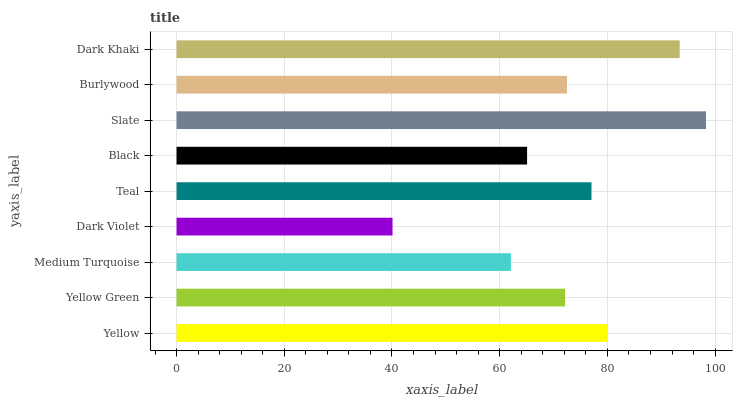Is Dark Violet the minimum?
Answer yes or no. Yes. Is Slate the maximum?
Answer yes or no. Yes. Is Yellow Green the minimum?
Answer yes or no. No. Is Yellow Green the maximum?
Answer yes or no. No. Is Yellow greater than Yellow Green?
Answer yes or no. Yes. Is Yellow Green less than Yellow?
Answer yes or no. Yes. Is Yellow Green greater than Yellow?
Answer yes or no. No. Is Yellow less than Yellow Green?
Answer yes or no. No. Is Burlywood the high median?
Answer yes or no. Yes. Is Burlywood the low median?
Answer yes or no. Yes. Is Slate the high median?
Answer yes or no. No. Is Dark Khaki the low median?
Answer yes or no. No. 